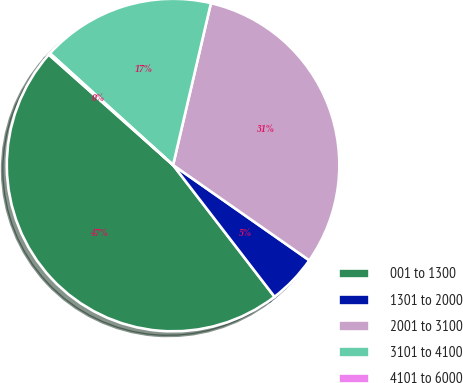<chart> <loc_0><loc_0><loc_500><loc_500><pie_chart><fcel>001 to 1300<fcel>1301 to 2000<fcel>2001 to 3100<fcel>3101 to 4100<fcel>4101 to 6000<nl><fcel>47.01%<fcel>4.84%<fcel>31.06%<fcel>16.93%<fcel>0.16%<nl></chart> 